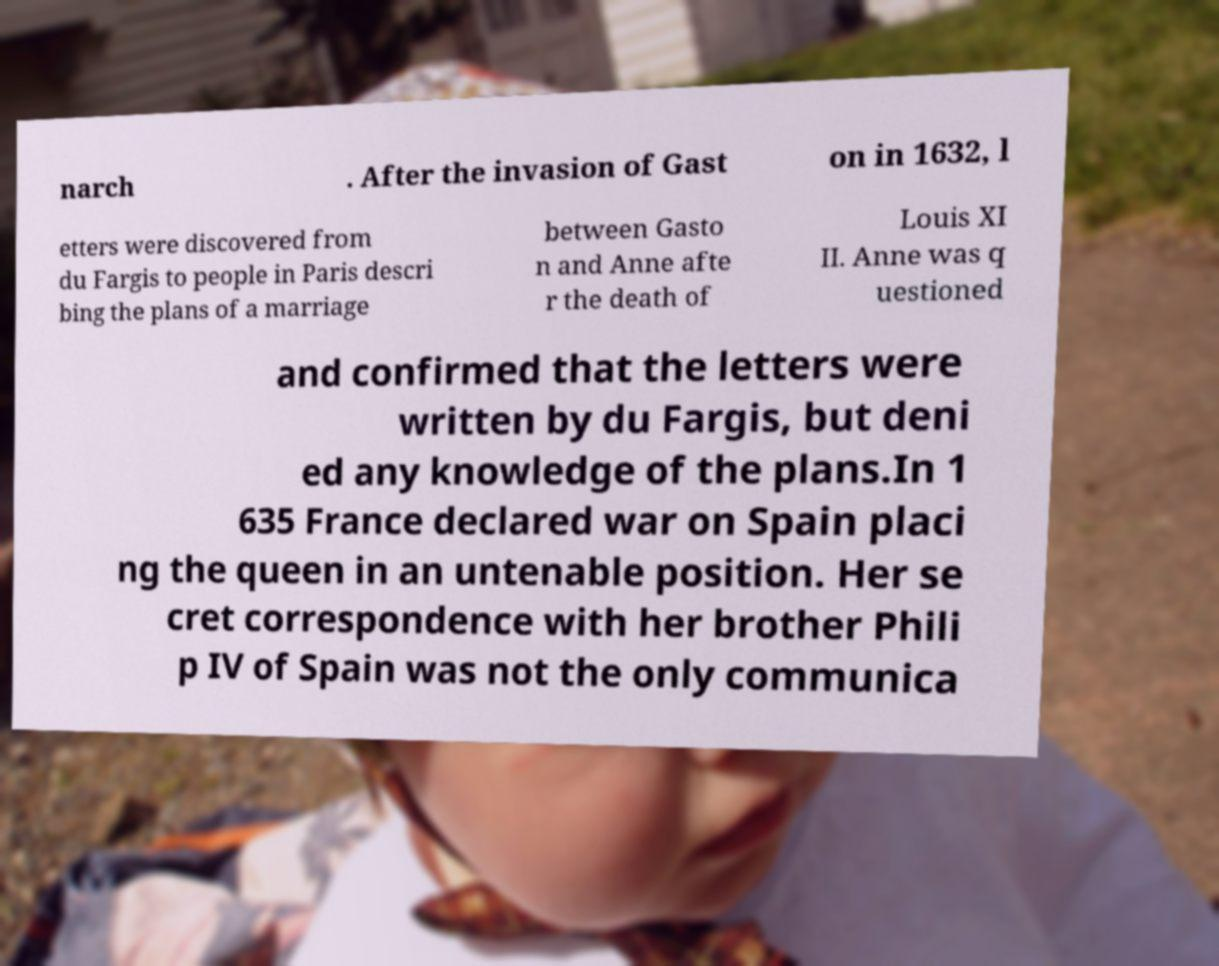Can you accurately transcribe the text from the provided image for me? narch . After the invasion of Gast on in 1632, l etters were discovered from du Fargis to people in Paris descri bing the plans of a marriage between Gasto n and Anne afte r the death of Louis XI II. Anne was q uestioned and confirmed that the letters were written by du Fargis, but deni ed any knowledge of the plans.In 1 635 France declared war on Spain placi ng the queen in an untenable position. Her se cret correspondence with her brother Phili p IV of Spain was not the only communica 